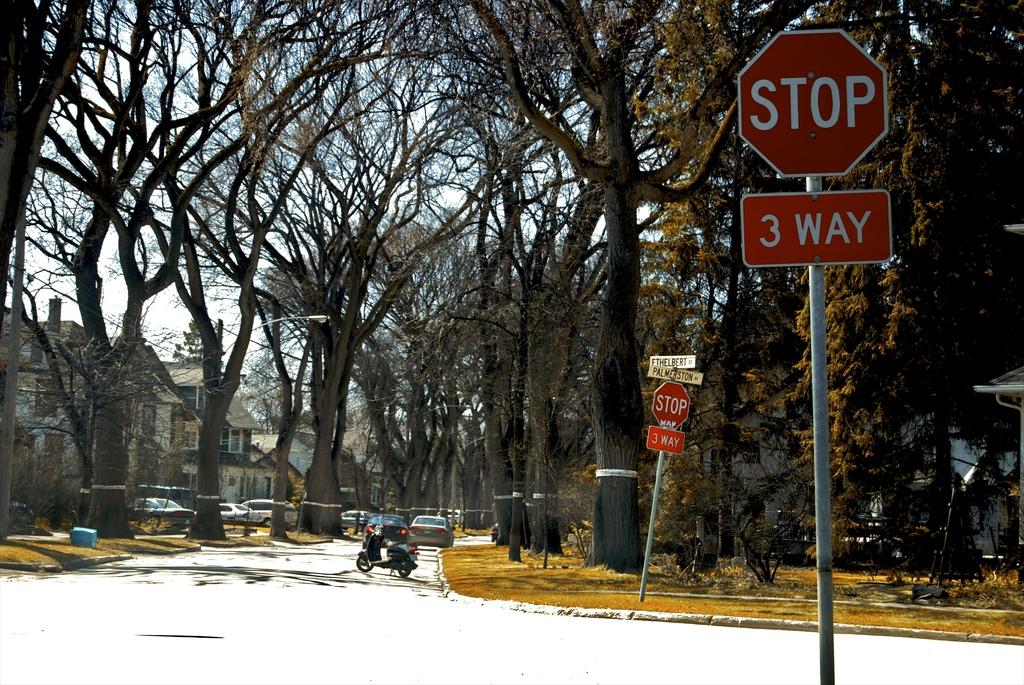How many way stop is this?
Make the answer very short. 3. What does the sign above the 3 way sign say?
Make the answer very short. Stop. 